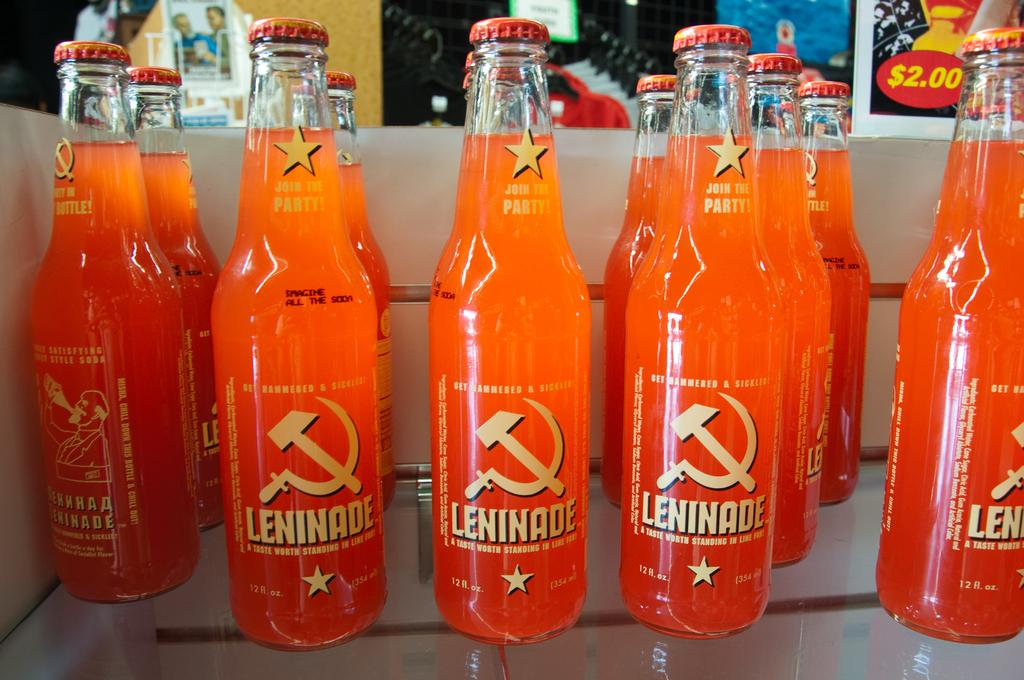<image>
Present a compact description of the photo's key features. Many bottles of orange Leninade on a glass shelf. 